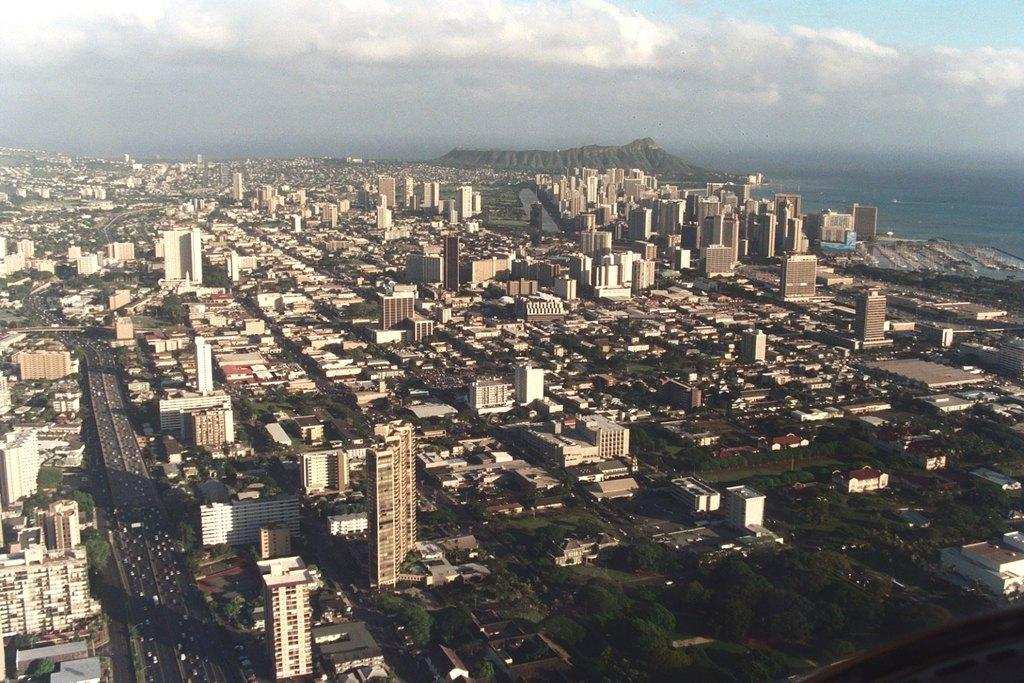What type of view is provided in the image? The image is an aerial view. What can be seen from this perspective? There are many buildings, trees, and roads visible in the image. Can you describe the terrain in the image? There is a hill present in the image. What is visible at the top of the image? The sky is visible at the top of the image. How much pollution is visible in the image? There is no indication of pollution in the image; it only shows an aerial view of buildings, trees, roads, a hill, and the sky. 